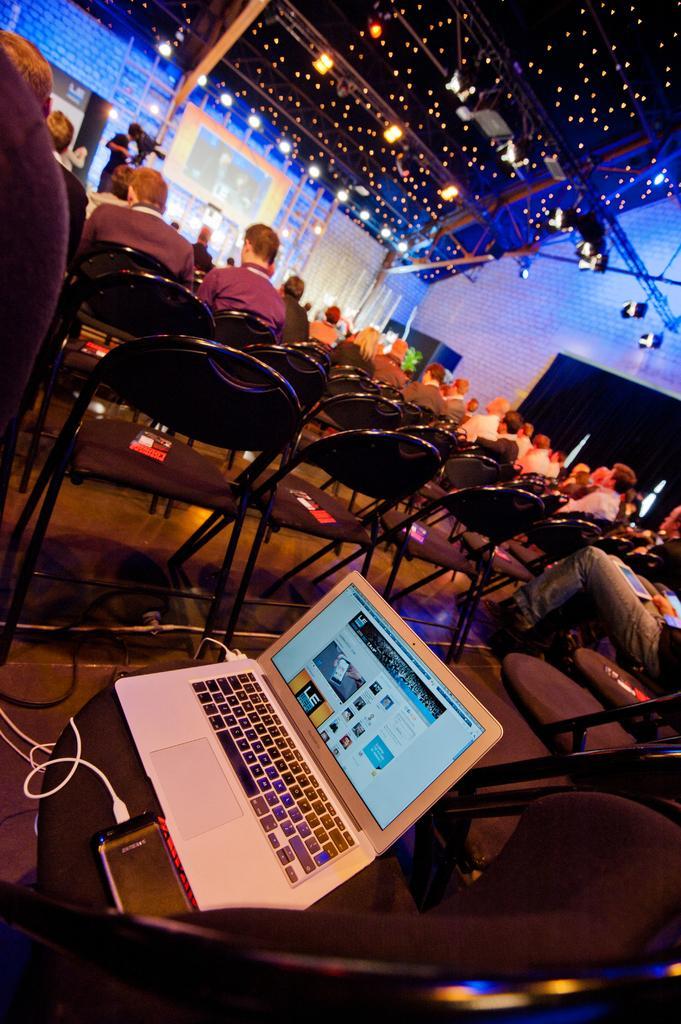Describe this image in one or two sentences. In this image we can see people sitting in the chairs and there is a laptop on the chair, on the top of the roof we can see the poles and lights. 